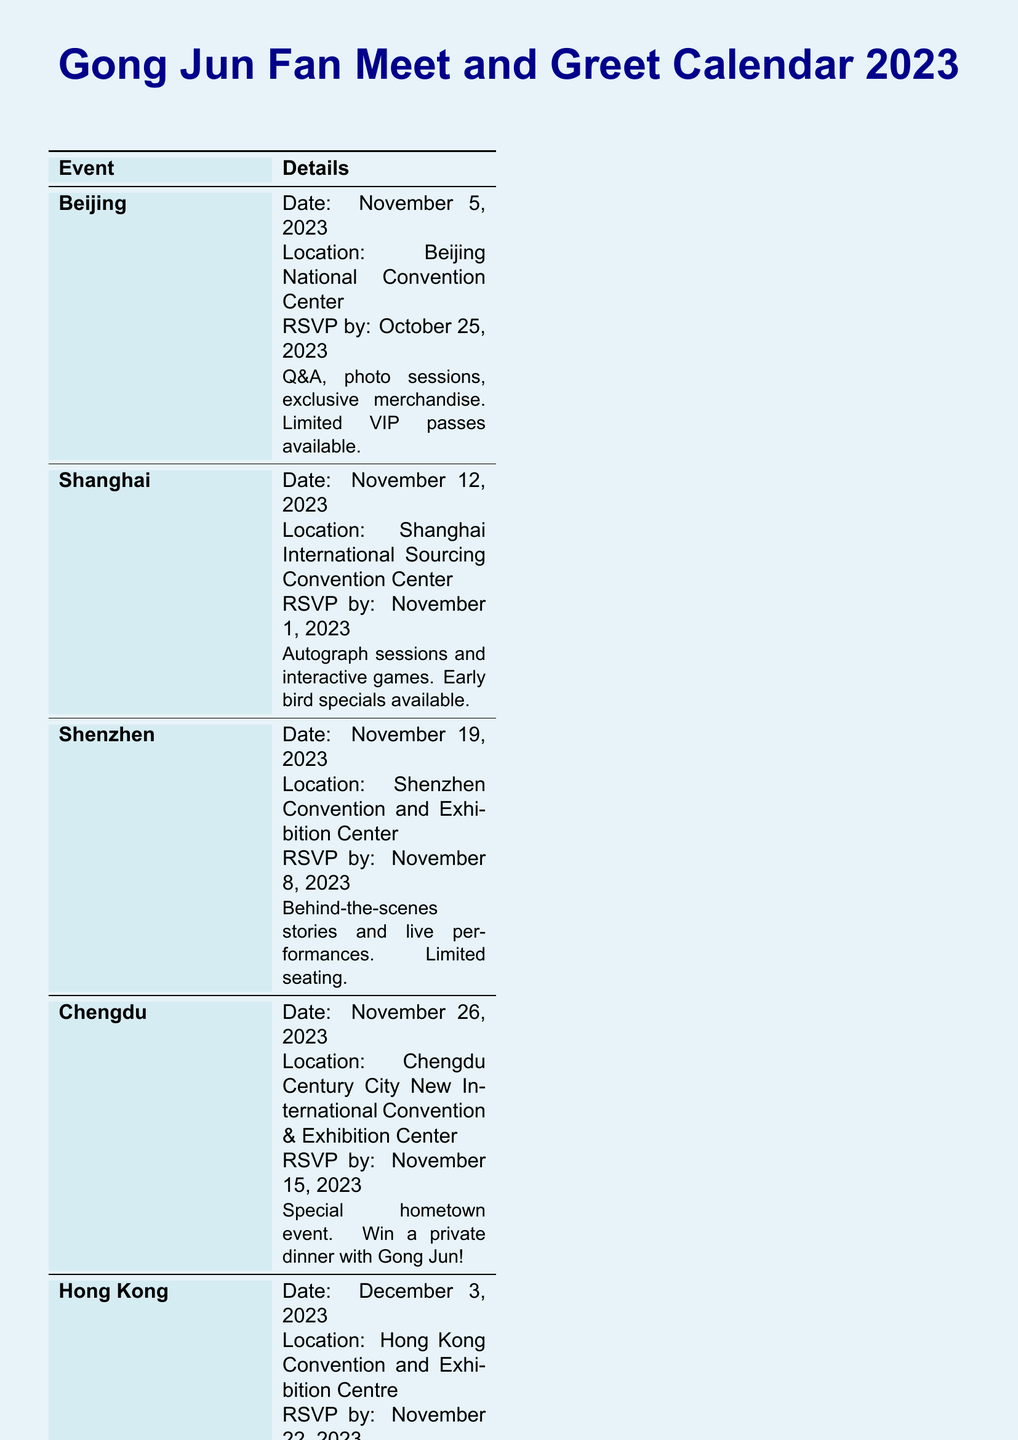what is the date of the Beijing event? The date of the Beijing event is explicitly stated in the document.
Answer: November 5, 2023 where is the Shenzhen meet and greet located? The document specifies the location for the Shenzhen event.
Answer: Shenzhen Convention and Exhibition Center when is the RSVP deadline for the Shanghai event? The RSVP deadline is clearly mentioned in the information for the Shanghai event.
Answer: November 1, 2023 which event offers a chance to win a private dinner with Gong Jun? The document lists specific activities for each event, including special ones.
Answer: Chengdu how many total locations are mentioned in the document? The document lists five locations for the events.
Answer: 5 what type of activities will be held in Hong Kong? The document indicates the types of activities planned for the Hong Kong event.
Answer: Performances, games, and lucky draws for which city is the hometown event scheduled? The document provides details about a special hometown event.
Answer: Chengdu which event has limited VIP passes available? The details about the availability of VIP passes are mentioned explicitly.
Answer: Beijing 